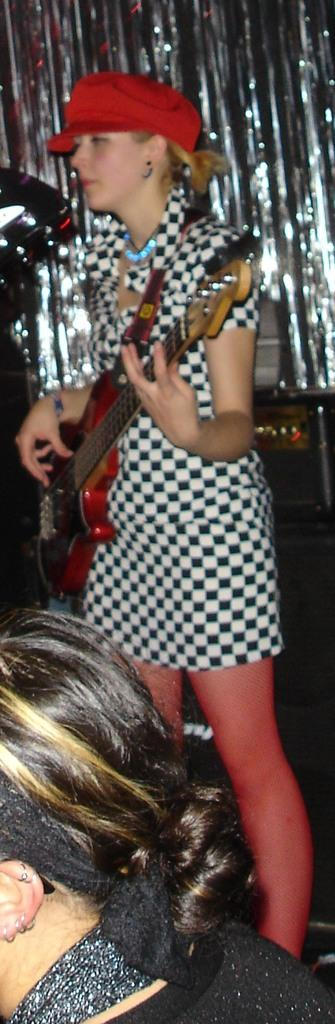Who is the main subject in the image? There is a woman in the image. What is the woman doing in the image? The woman is standing in the image. What object is the woman holding in her hand? The woman is holding a guitar in her hand. What type of juice is the woman drinking in the image? There is no juice present in the image; the woman is holding a guitar. 